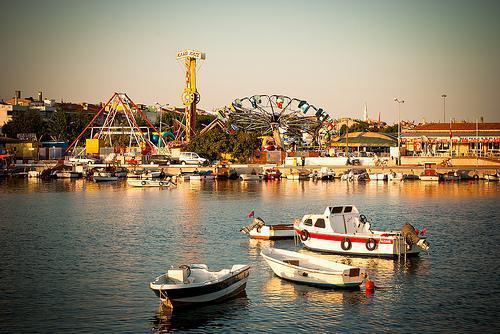How many tires on the side of the boat?
Give a very brief answer. 3. How many boats in the foreground?
Give a very brief answer. 4. 